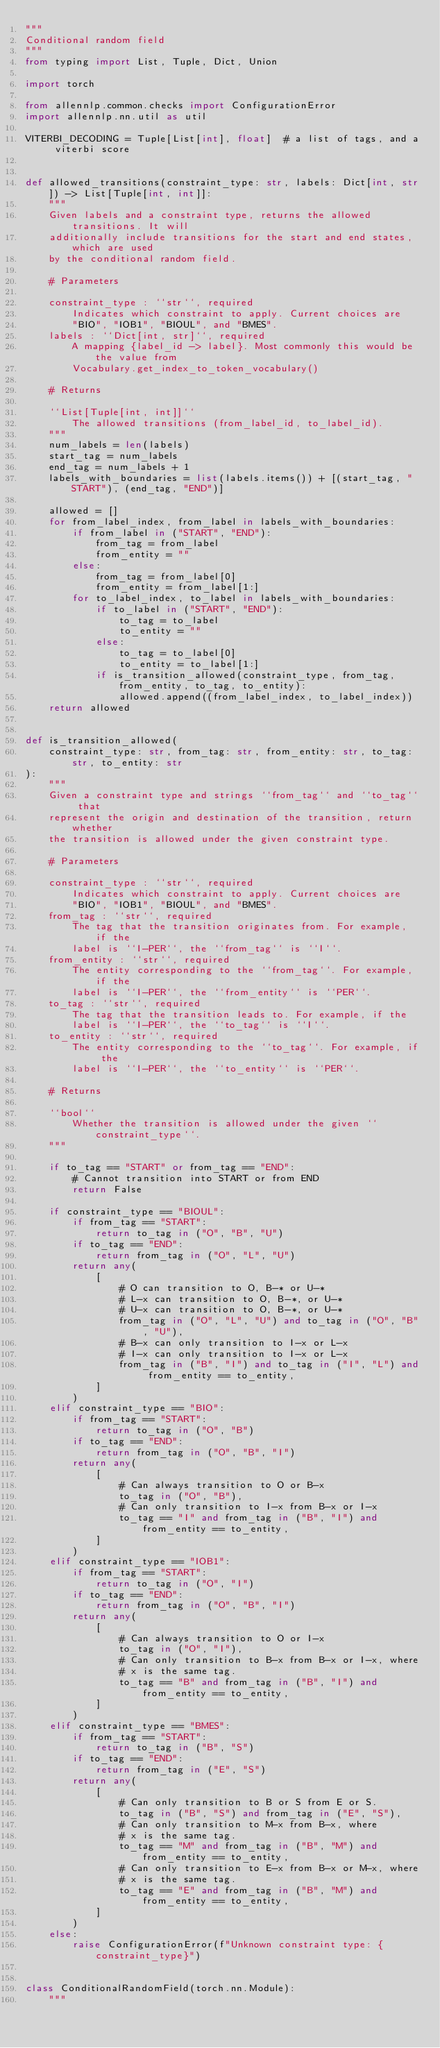<code> <loc_0><loc_0><loc_500><loc_500><_Python_>"""
Conditional random field
"""
from typing import List, Tuple, Dict, Union

import torch

from allennlp.common.checks import ConfigurationError
import allennlp.nn.util as util

VITERBI_DECODING = Tuple[List[int], float]  # a list of tags, and a viterbi score


def allowed_transitions(constraint_type: str, labels: Dict[int, str]) -> List[Tuple[int, int]]:
    """
    Given labels and a constraint type, returns the allowed transitions. It will
    additionally include transitions for the start and end states, which are used
    by the conditional random field.

    # Parameters

    constraint_type : ``str``, required
        Indicates which constraint to apply. Current choices are
        "BIO", "IOB1", "BIOUL", and "BMES".
    labels : ``Dict[int, str]``, required
        A mapping {label_id -> label}. Most commonly this would be the value from
        Vocabulary.get_index_to_token_vocabulary()

    # Returns

    ``List[Tuple[int, int]]``
        The allowed transitions (from_label_id, to_label_id).
    """
    num_labels = len(labels)
    start_tag = num_labels
    end_tag = num_labels + 1
    labels_with_boundaries = list(labels.items()) + [(start_tag, "START"), (end_tag, "END")]

    allowed = []
    for from_label_index, from_label in labels_with_boundaries:
        if from_label in ("START", "END"):
            from_tag = from_label
            from_entity = ""
        else:
            from_tag = from_label[0]
            from_entity = from_label[1:]
        for to_label_index, to_label in labels_with_boundaries:
            if to_label in ("START", "END"):
                to_tag = to_label
                to_entity = ""
            else:
                to_tag = to_label[0]
                to_entity = to_label[1:]
            if is_transition_allowed(constraint_type, from_tag, from_entity, to_tag, to_entity):
                allowed.append((from_label_index, to_label_index))
    return allowed


def is_transition_allowed(
    constraint_type: str, from_tag: str, from_entity: str, to_tag: str, to_entity: str
):
    """
    Given a constraint type and strings ``from_tag`` and ``to_tag`` that
    represent the origin and destination of the transition, return whether
    the transition is allowed under the given constraint type.

    # Parameters

    constraint_type : ``str``, required
        Indicates which constraint to apply. Current choices are
        "BIO", "IOB1", "BIOUL", and "BMES".
    from_tag : ``str``, required
        The tag that the transition originates from. For example, if the
        label is ``I-PER``, the ``from_tag`` is ``I``.
    from_entity : ``str``, required
        The entity corresponding to the ``from_tag``. For example, if the
        label is ``I-PER``, the ``from_entity`` is ``PER``.
    to_tag : ``str``, required
        The tag that the transition leads to. For example, if the
        label is ``I-PER``, the ``to_tag`` is ``I``.
    to_entity : ``str``, required
        The entity corresponding to the ``to_tag``. For example, if the
        label is ``I-PER``, the ``to_entity`` is ``PER``.

    # Returns

    ``bool``
        Whether the transition is allowed under the given ``constraint_type``.
    """

    if to_tag == "START" or from_tag == "END":
        # Cannot transition into START or from END
        return False

    if constraint_type == "BIOUL":
        if from_tag == "START":
            return to_tag in ("O", "B", "U")
        if to_tag == "END":
            return from_tag in ("O", "L", "U")
        return any(
            [
                # O can transition to O, B-* or U-*
                # L-x can transition to O, B-*, or U-*
                # U-x can transition to O, B-*, or U-*
                from_tag in ("O", "L", "U") and to_tag in ("O", "B", "U"),
                # B-x can only transition to I-x or L-x
                # I-x can only transition to I-x or L-x
                from_tag in ("B", "I") and to_tag in ("I", "L") and from_entity == to_entity,
            ]
        )
    elif constraint_type == "BIO":
        if from_tag == "START":
            return to_tag in ("O", "B")
        if to_tag == "END":
            return from_tag in ("O", "B", "I")
        return any(
            [
                # Can always transition to O or B-x
                to_tag in ("O", "B"),
                # Can only transition to I-x from B-x or I-x
                to_tag == "I" and from_tag in ("B", "I") and from_entity == to_entity,
            ]
        )
    elif constraint_type == "IOB1":
        if from_tag == "START":
            return to_tag in ("O", "I")
        if to_tag == "END":
            return from_tag in ("O", "B", "I")
        return any(
            [
                # Can always transition to O or I-x
                to_tag in ("O", "I"),
                # Can only transition to B-x from B-x or I-x, where
                # x is the same tag.
                to_tag == "B" and from_tag in ("B", "I") and from_entity == to_entity,
            ]
        )
    elif constraint_type == "BMES":
        if from_tag == "START":
            return to_tag in ("B", "S")
        if to_tag == "END":
            return from_tag in ("E", "S")
        return any(
            [
                # Can only transition to B or S from E or S.
                to_tag in ("B", "S") and from_tag in ("E", "S"),
                # Can only transition to M-x from B-x, where
                # x is the same tag.
                to_tag == "M" and from_tag in ("B", "M") and from_entity == to_entity,
                # Can only transition to E-x from B-x or M-x, where
                # x is the same tag.
                to_tag == "E" and from_tag in ("B", "M") and from_entity == to_entity,
            ]
        )
    else:
        raise ConfigurationError(f"Unknown constraint type: {constraint_type}")


class ConditionalRandomField(torch.nn.Module):
    """</code> 